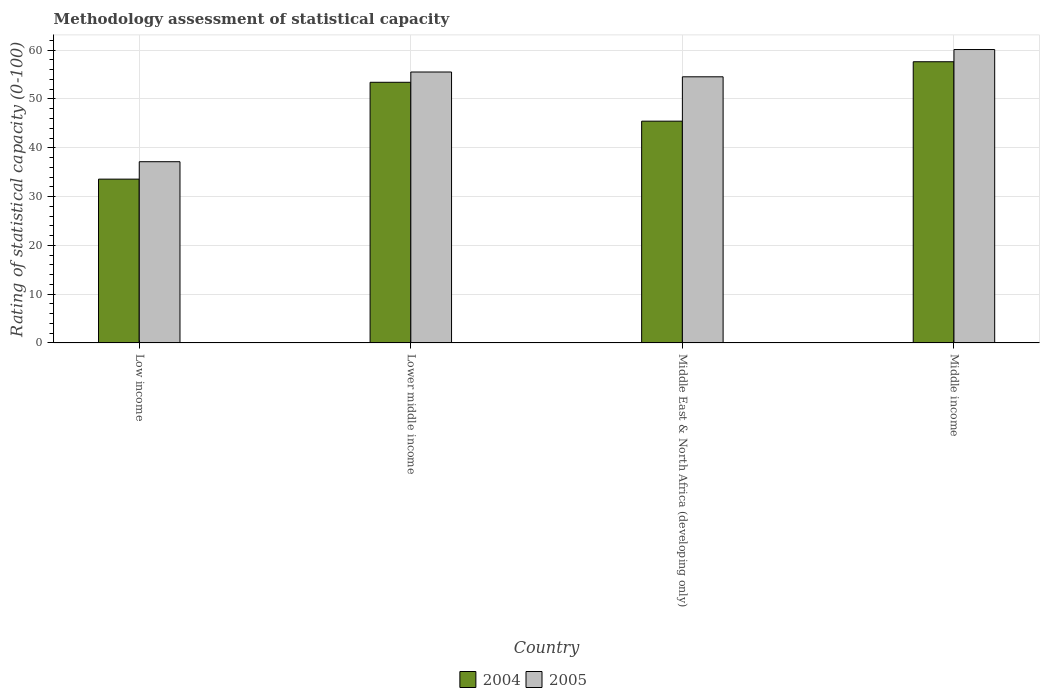How many groups of bars are there?
Your response must be concise. 4. How many bars are there on the 4th tick from the right?
Offer a terse response. 2. What is the rating of statistical capacity in 2005 in Lower middle income?
Your answer should be compact. 55.53. Across all countries, what is the maximum rating of statistical capacity in 2005?
Your answer should be very brief. 60.13. Across all countries, what is the minimum rating of statistical capacity in 2004?
Offer a terse response. 33.57. In which country was the rating of statistical capacity in 2005 minimum?
Make the answer very short. Low income. What is the total rating of statistical capacity in 2004 in the graph?
Provide a short and direct response. 190.08. What is the difference between the rating of statistical capacity in 2004 in Low income and that in Lower middle income?
Provide a succinct answer. -19.85. What is the difference between the rating of statistical capacity in 2004 in Lower middle income and the rating of statistical capacity in 2005 in Low income?
Provide a succinct answer. 16.28. What is the average rating of statistical capacity in 2005 per country?
Ensure brevity in your answer.  51.84. What is the difference between the rating of statistical capacity of/in 2005 and rating of statistical capacity of/in 2004 in Lower middle income?
Your answer should be very brief. 2.11. What is the ratio of the rating of statistical capacity in 2005 in Lower middle income to that in Middle East & North Africa (developing only)?
Provide a succinct answer. 1.02. Is the rating of statistical capacity in 2004 in Low income less than that in Middle East & North Africa (developing only)?
Your response must be concise. Yes. Is the difference between the rating of statistical capacity in 2005 in Low income and Lower middle income greater than the difference between the rating of statistical capacity in 2004 in Low income and Lower middle income?
Make the answer very short. Yes. What is the difference between the highest and the second highest rating of statistical capacity in 2005?
Your response must be concise. 5.59. What is the difference between the highest and the lowest rating of statistical capacity in 2004?
Offer a very short reply. 24.06. What does the 2nd bar from the left in Low income represents?
Offer a very short reply. 2005. What does the 2nd bar from the right in Middle East & North Africa (developing only) represents?
Your answer should be compact. 2004. How many countries are there in the graph?
Make the answer very short. 4. Are the values on the major ticks of Y-axis written in scientific E-notation?
Your answer should be very brief. No. Where does the legend appear in the graph?
Your answer should be compact. Bottom center. What is the title of the graph?
Offer a very short reply. Methodology assessment of statistical capacity. Does "1973" appear as one of the legend labels in the graph?
Offer a very short reply. No. What is the label or title of the X-axis?
Provide a short and direct response. Country. What is the label or title of the Y-axis?
Provide a succinct answer. Rating of statistical capacity (0-100). What is the Rating of statistical capacity (0-100) of 2004 in Low income?
Keep it short and to the point. 33.57. What is the Rating of statistical capacity (0-100) in 2005 in Low income?
Keep it short and to the point. 37.14. What is the Rating of statistical capacity (0-100) of 2004 in Lower middle income?
Provide a short and direct response. 53.42. What is the Rating of statistical capacity (0-100) of 2005 in Lower middle income?
Provide a succinct answer. 55.53. What is the Rating of statistical capacity (0-100) in 2004 in Middle East & North Africa (developing only)?
Ensure brevity in your answer.  45.45. What is the Rating of statistical capacity (0-100) of 2005 in Middle East & North Africa (developing only)?
Provide a succinct answer. 54.55. What is the Rating of statistical capacity (0-100) in 2004 in Middle income?
Your answer should be very brief. 57.63. What is the Rating of statistical capacity (0-100) of 2005 in Middle income?
Make the answer very short. 60.13. Across all countries, what is the maximum Rating of statistical capacity (0-100) in 2004?
Make the answer very short. 57.63. Across all countries, what is the maximum Rating of statistical capacity (0-100) in 2005?
Provide a succinct answer. 60.13. Across all countries, what is the minimum Rating of statistical capacity (0-100) in 2004?
Your answer should be compact. 33.57. Across all countries, what is the minimum Rating of statistical capacity (0-100) in 2005?
Offer a very short reply. 37.14. What is the total Rating of statistical capacity (0-100) in 2004 in the graph?
Offer a terse response. 190.08. What is the total Rating of statistical capacity (0-100) in 2005 in the graph?
Give a very brief answer. 207.35. What is the difference between the Rating of statistical capacity (0-100) of 2004 in Low income and that in Lower middle income?
Give a very brief answer. -19.85. What is the difference between the Rating of statistical capacity (0-100) of 2005 in Low income and that in Lower middle income?
Keep it short and to the point. -18.38. What is the difference between the Rating of statistical capacity (0-100) in 2004 in Low income and that in Middle East & North Africa (developing only)?
Provide a succinct answer. -11.88. What is the difference between the Rating of statistical capacity (0-100) of 2005 in Low income and that in Middle East & North Africa (developing only)?
Give a very brief answer. -17.4. What is the difference between the Rating of statistical capacity (0-100) in 2004 in Low income and that in Middle income?
Ensure brevity in your answer.  -24.06. What is the difference between the Rating of statistical capacity (0-100) in 2005 in Low income and that in Middle income?
Offer a very short reply. -22.99. What is the difference between the Rating of statistical capacity (0-100) in 2004 in Lower middle income and that in Middle East & North Africa (developing only)?
Make the answer very short. 7.97. What is the difference between the Rating of statistical capacity (0-100) in 2005 in Lower middle income and that in Middle East & North Africa (developing only)?
Offer a terse response. 0.98. What is the difference between the Rating of statistical capacity (0-100) of 2004 in Lower middle income and that in Middle income?
Offer a very short reply. -4.21. What is the difference between the Rating of statistical capacity (0-100) of 2005 in Lower middle income and that in Middle income?
Offer a very short reply. -4.61. What is the difference between the Rating of statistical capacity (0-100) in 2004 in Middle East & North Africa (developing only) and that in Middle income?
Offer a very short reply. -12.18. What is the difference between the Rating of statistical capacity (0-100) in 2005 in Middle East & North Africa (developing only) and that in Middle income?
Provide a short and direct response. -5.59. What is the difference between the Rating of statistical capacity (0-100) in 2004 in Low income and the Rating of statistical capacity (0-100) in 2005 in Lower middle income?
Your response must be concise. -21.95. What is the difference between the Rating of statistical capacity (0-100) of 2004 in Low income and the Rating of statistical capacity (0-100) of 2005 in Middle East & North Africa (developing only)?
Make the answer very short. -20.97. What is the difference between the Rating of statistical capacity (0-100) in 2004 in Low income and the Rating of statistical capacity (0-100) in 2005 in Middle income?
Keep it short and to the point. -26.56. What is the difference between the Rating of statistical capacity (0-100) of 2004 in Lower middle income and the Rating of statistical capacity (0-100) of 2005 in Middle East & North Africa (developing only)?
Your answer should be very brief. -1.12. What is the difference between the Rating of statistical capacity (0-100) of 2004 in Lower middle income and the Rating of statistical capacity (0-100) of 2005 in Middle income?
Ensure brevity in your answer.  -6.71. What is the difference between the Rating of statistical capacity (0-100) of 2004 in Middle East & North Africa (developing only) and the Rating of statistical capacity (0-100) of 2005 in Middle income?
Your response must be concise. -14.68. What is the average Rating of statistical capacity (0-100) in 2004 per country?
Offer a very short reply. 47.52. What is the average Rating of statistical capacity (0-100) in 2005 per country?
Your answer should be compact. 51.84. What is the difference between the Rating of statistical capacity (0-100) of 2004 and Rating of statistical capacity (0-100) of 2005 in Low income?
Your answer should be compact. -3.57. What is the difference between the Rating of statistical capacity (0-100) in 2004 and Rating of statistical capacity (0-100) in 2005 in Lower middle income?
Give a very brief answer. -2.11. What is the difference between the Rating of statistical capacity (0-100) in 2004 and Rating of statistical capacity (0-100) in 2005 in Middle East & North Africa (developing only)?
Keep it short and to the point. -9.09. What is the difference between the Rating of statistical capacity (0-100) of 2004 and Rating of statistical capacity (0-100) of 2005 in Middle income?
Provide a short and direct response. -2.5. What is the ratio of the Rating of statistical capacity (0-100) of 2004 in Low income to that in Lower middle income?
Make the answer very short. 0.63. What is the ratio of the Rating of statistical capacity (0-100) in 2005 in Low income to that in Lower middle income?
Give a very brief answer. 0.67. What is the ratio of the Rating of statistical capacity (0-100) in 2004 in Low income to that in Middle East & North Africa (developing only)?
Provide a succinct answer. 0.74. What is the ratio of the Rating of statistical capacity (0-100) of 2005 in Low income to that in Middle East & North Africa (developing only)?
Give a very brief answer. 0.68. What is the ratio of the Rating of statistical capacity (0-100) in 2004 in Low income to that in Middle income?
Your answer should be compact. 0.58. What is the ratio of the Rating of statistical capacity (0-100) in 2005 in Low income to that in Middle income?
Your answer should be very brief. 0.62. What is the ratio of the Rating of statistical capacity (0-100) in 2004 in Lower middle income to that in Middle East & North Africa (developing only)?
Provide a short and direct response. 1.18. What is the ratio of the Rating of statistical capacity (0-100) in 2004 in Lower middle income to that in Middle income?
Ensure brevity in your answer.  0.93. What is the ratio of the Rating of statistical capacity (0-100) of 2005 in Lower middle income to that in Middle income?
Offer a terse response. 0.92. What is the ratio of the Rating of statistical capacity (0-100) in 2004 in Middle East & North Africa (developing only) to that in Middle income?
Provide a short and direct response. 0.79. What is the ratio of the Rating of statistical capacity (0-100) in 2005 in Middle East & North Africa (developing only) to that in Middle income?
Your answer should be very brief. 0.91. What is the difference between the highest and the second highest Rating of statistical capacity (0-100) of 2004?
Your response must be concise. 4.21. What is the difference between the highest and the second highest Rating of statistical capacity (0-100) of 2005?
Your response must be concise. 4.61. What is the difference between the highest and the lowest Rating of statistical capacity (0-100) in 2004?
Your answer should be very brief. 24.06. What is the difference between the highest and the lowest Rating of statistical capacity (0-100) of 2005?
Ensure brevity in your answer.  22.99. 